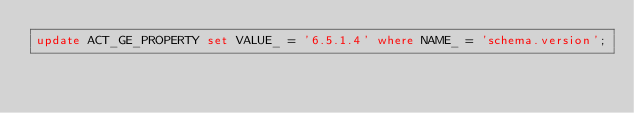<code> <loc_0><loc_0><loc_500><loc_500><_SQL_>update ACT_GE_PROPERTY set VALUE_ = '6.5.1.4' where NAME_ = 'schema.version';
</code> 